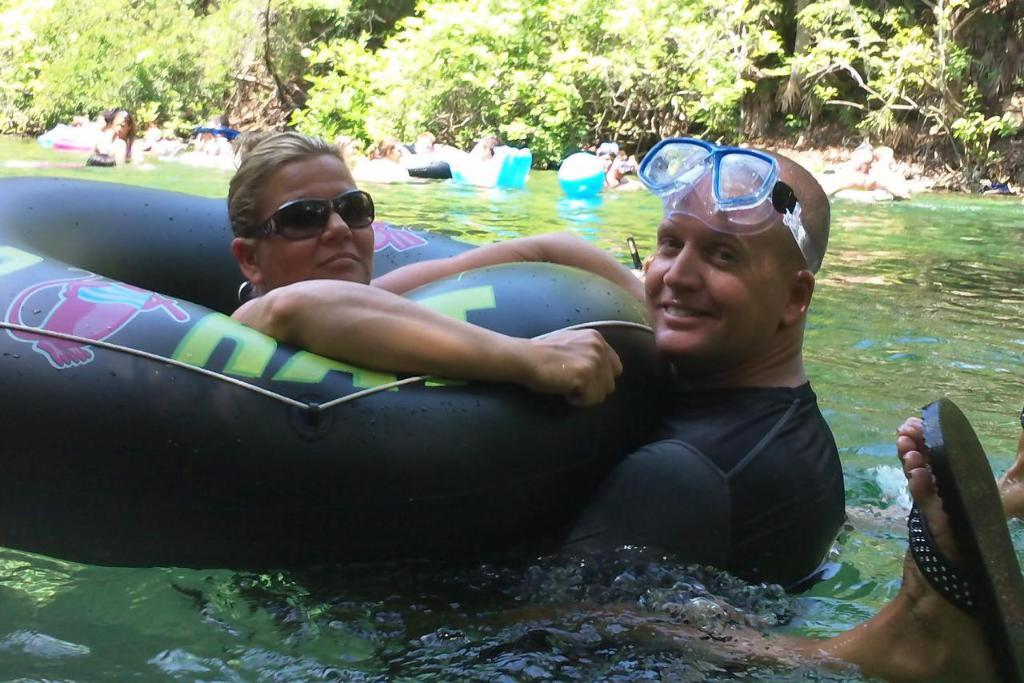What are the people in the swimming pool doing? The man and woman are holding a black color tube and giving a pose to the camera. What is the emotional state of the people in the swimming pool? The man and woman are smiling, indicating a positive emotional state. What can be seen in the background of the image? There are trees visible in the background. Can you see any rays of light shining on the island in the image? There is no island present in the image, and therefore no rays of light shining on it. What is the man's wish while holding the tube in the image? There is no information about the man's wish in the image, as it only shows him holding a black color tube and posing for the camera. 